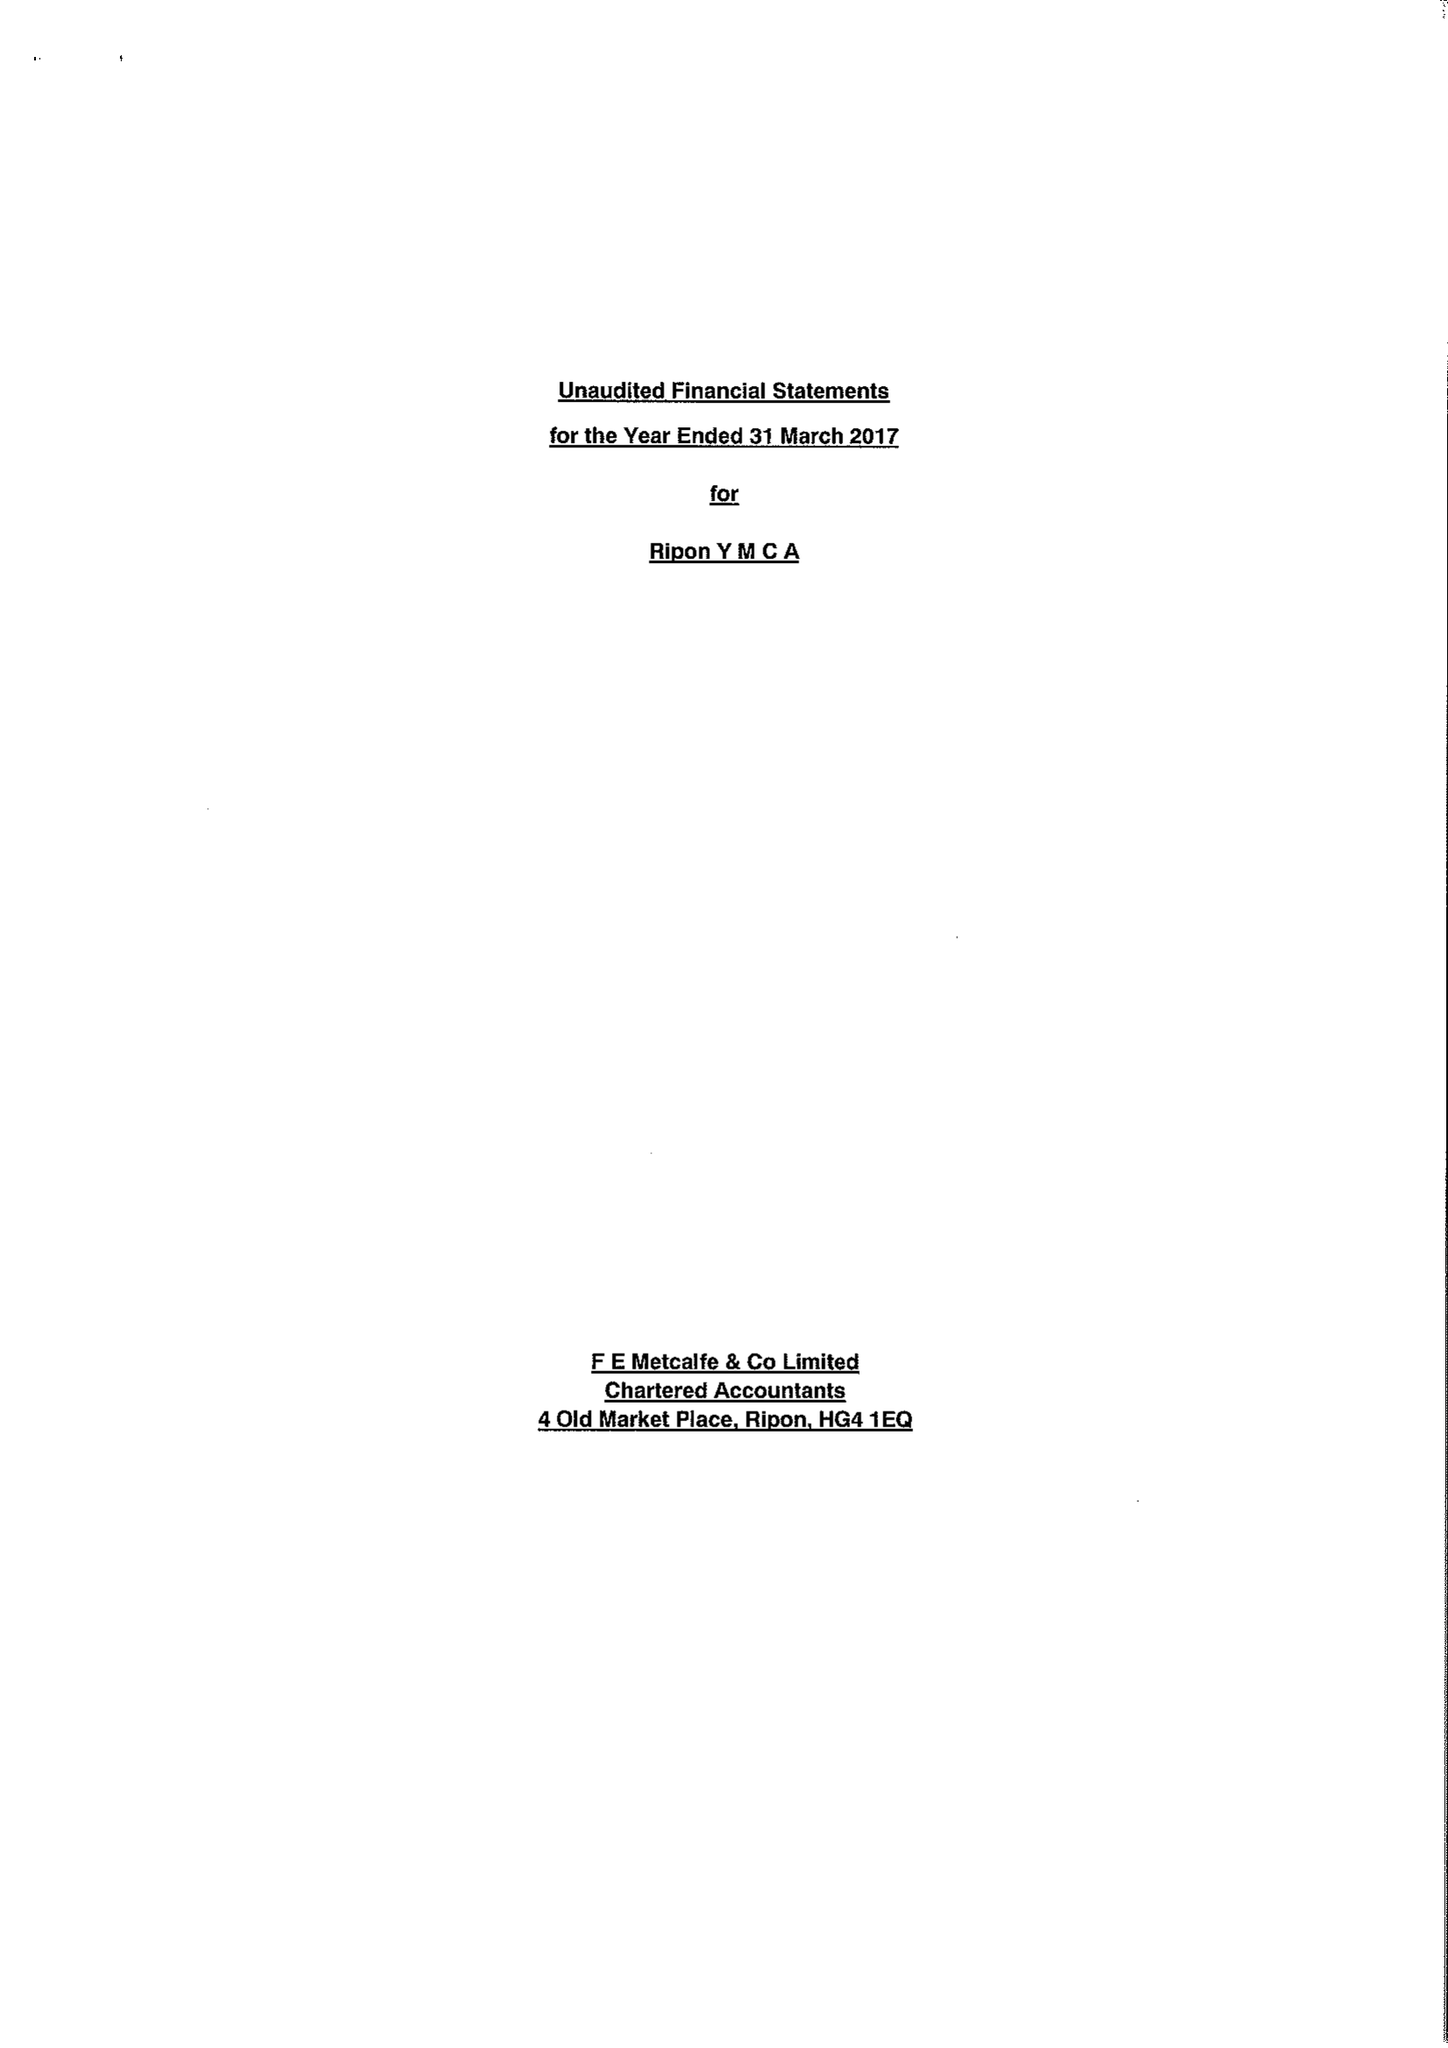What is the value for the charity_number?
Answer the question using a single word or phrase. 250986 